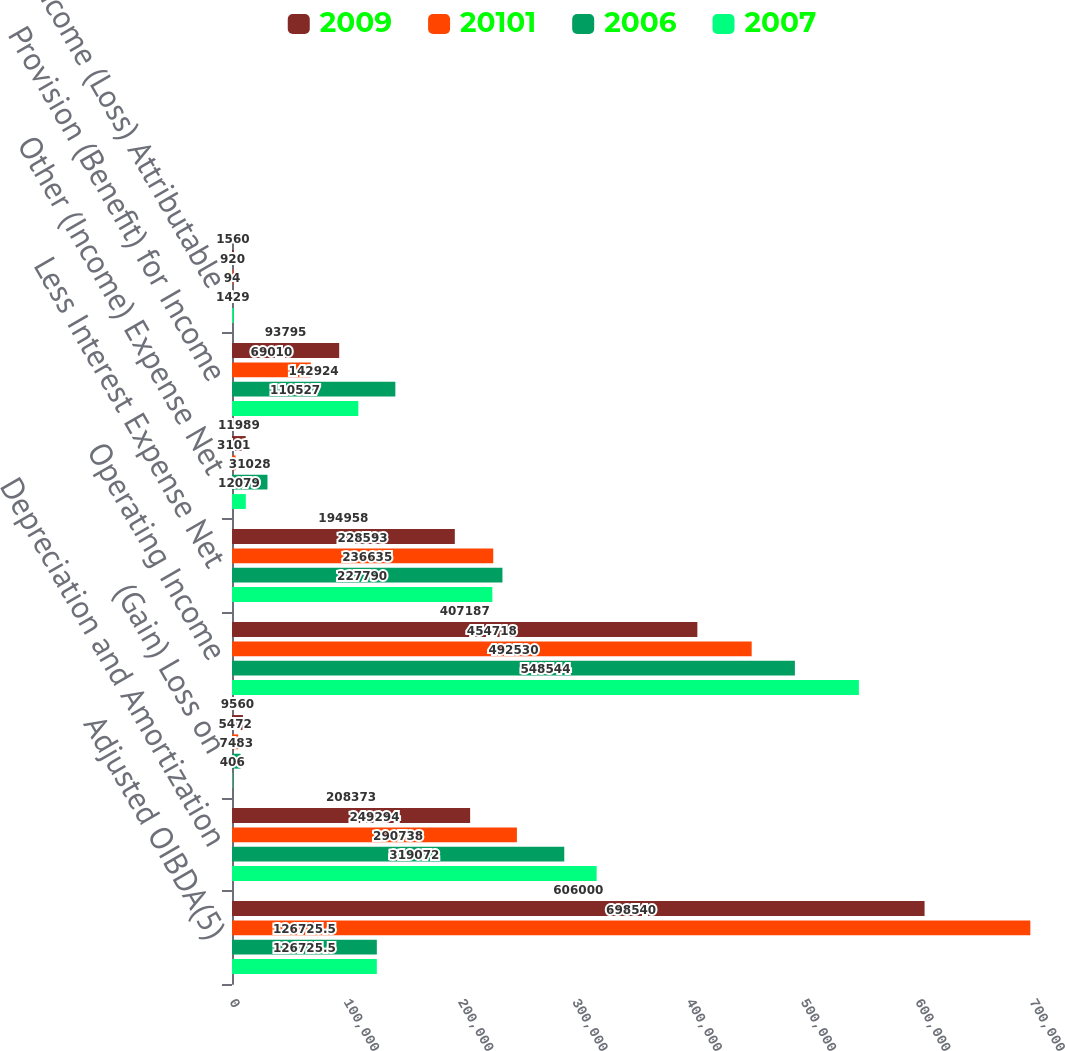Convert chart. <chart><loc_0><loc_0><loc_500><loc_500><stacked_bar_chart><ecel><fcel>Adjusted OIBDA(5)<fcel>Depreciation and Amortization<fcel>(Gain) Loss on<fcel>Operating Income<fcel>Less Interest Expense Net<fcel>Other (Income) Expense Net<fcel>Provision (Benefit) for Income<fcel>Net Income (Loss) Attributable<nl><fcel>2009<fcel>606000<fcel>208373<fcel>9560<fcel>407187<fcel>194958<fcel>11989<fcel>93795<fcel>1560<nl><fcel>20101<fcel>698540<fcel>249294<fcel>5472<fcel>454718<fcel>228593<fcel>3101<fcel>69010<fcel>920<nl><fcel>2006<fcel>126726<fcel>290738<fcel>7483<fcel>492530<fcel>236635<fcel>31028<fcel>142924<fcel>94<nl><fcel>2007<fcel>126726<fcel>319072<fcel>406<fcel>548544<fcel>227790<fcel>12079<fcel>110527<fcel>1429<nl></chart> 